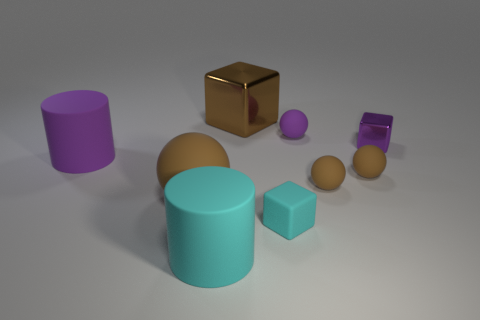What size is the cyan cylinder that is made of the same material as the large purple thing?
Your answer should be compact. Large. What number of tiny balls have the same color as the tiny metal object?
Your response must be concise. 1. How many tiny objects are either gray balls or cyan cylinders?
Offer a terse response. 0. There is a metal thing that is the same color as the large ball; what is its size?
Make the answer very short. Large. Are there any tiny things that have the same material as the big block?
Offer a very short reply. Yes. What is the material of the cube behind the purple block?
Provide a succinct answer. Metal. There is a metallic object that is in front of the large cube; does it have the same color as the matte ball that is behind the small purple metal block?
Your answer should be very brief. Yes. The matte block that is the same size as the purple metal block is what color?
Keep it short and to the point. Cyan. How many other objects are the same shape as the purple metal object?
Your response must be concise. 2. There is a brown metal thing that is behind the tiny cyan matte block; what size is it?
Provide a succinct answer. Large. 